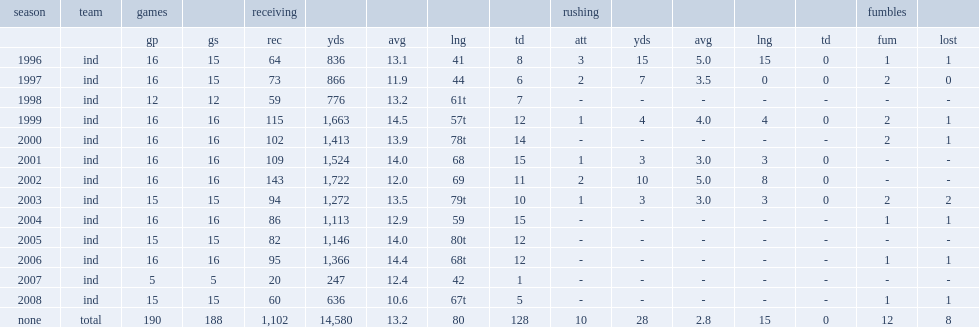How many receptions did marvin harrison score totally? 1102.0. 